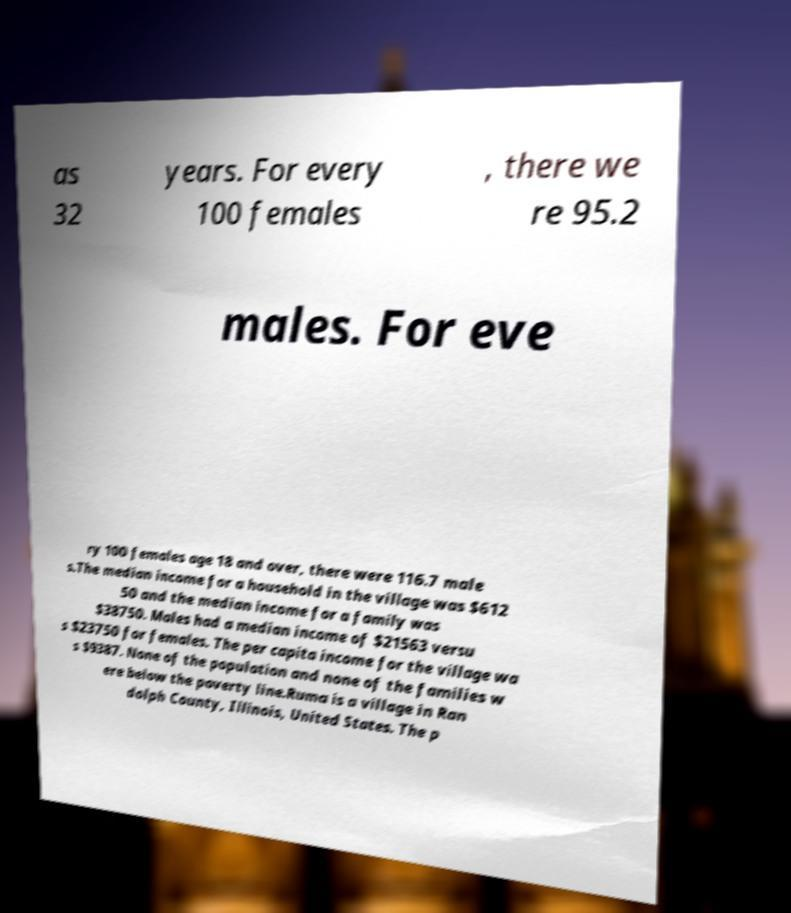I need the written content from this picture converted into text. Can you do that? as 32 years. For every 100 females , there we re 95.2 males. For eve ry 100 females age 18 and over, there were 116.7 male s.The median income for a household in the village was $612 50 and the median income for a family was $38750. Males had a median income of $21563 versu s $23750 for females. The per capita income for the village wa s $9387. None of the population and none of the families w ere below the poverty line.Ruma is a village in Ran dolph County, Illinois, United States. The p 